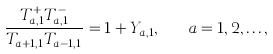<formula> <loc_0><loc_0><loc_500><loc_500>\frac { T _ { a , 1 } ^ { + } T _ { a , 1 } ^ { - } } { T _ { a + 1 , 1 } T _ { a - 1 , 1 } } = 1 + Y _ { a , 1 } , \quad a = 1 , 2 , \dots ,</formula> 